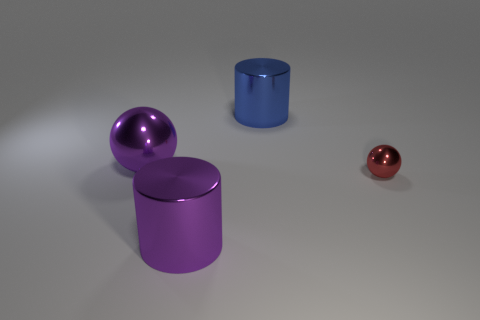There is a large cylinder that is the same color as the big ball; what is its material?
Give a very brief answer. Metal. What size is the sphere left of the metallic cylinder that is on the left side of the blue shiny cylinder?
Offer a terse response. Large. How many spheres have the same size as the red thing?
Provide a succinct answer. 0. Do the thing that is on the right side of the blue metal thing and the cylinder that is in front of the big blue object have the same color?
Provide a succinct answer. No. There is a red shiny ball; are there any purple things in front of it?
Ensure brevity in your answer.  Yes. What is the color of the big metallic thing that is behind the tiny metallic sphere and on the left side of the big blue shiny cylinder?
Your response must be concise. Purple. Are there any metallic things of the same color as the big sphere?
Your answer should be very brief. Yes. Do the large cylinder that is behind the purple shiny sphere and the large cylinder that is on the left side of the blue metallic object have the same material?
Ensure brevity in your answer.  Yes. There is a cylinder that is in front of the blue metal cylinder; how big is it?
Your answer should be compact. Large. How big is the red object?
Your answer should be very brief. Small. 